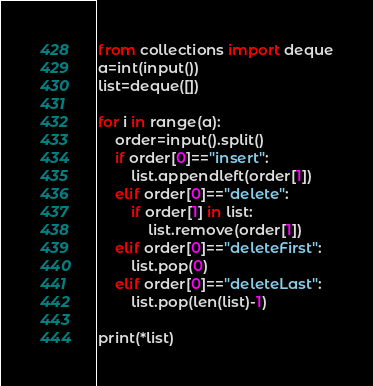Convert code to text. <code><loc_0><loc_0><loc_500><loc_500><_Python_>from collections import deque
a=int(input())
list=deque([])

for i in range(a):
    order=input().split()
    if order[0]=="insert":
        list.appendleft(order[1])
    elif order[0]=="delete":
        if order[1] in list:
            list.remove(order[1])
    elif order[0]=="deleteFirst":
        list.pop(0)
    elif order[0]=="deleteLast":
        list.pop(len(list)-1)

print(*list)
</code> 